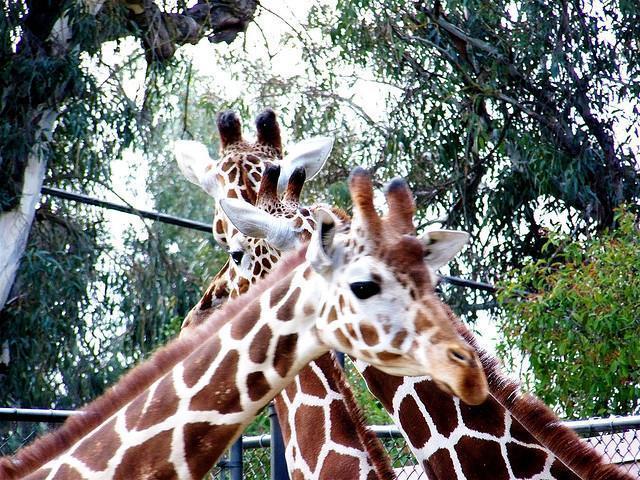How many giraffes are there?
Give a very brief answer. 3. How many giraffes can you see?
Give a very brief answer. 3. How many girls are in the scene?
Give a very brief answer. 0. 